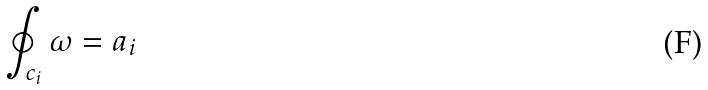<formula> <loc_0><loc_0><loc_500><loc_500>\oint _ { c _ { i } } \omega = a _ { i }</formula> 